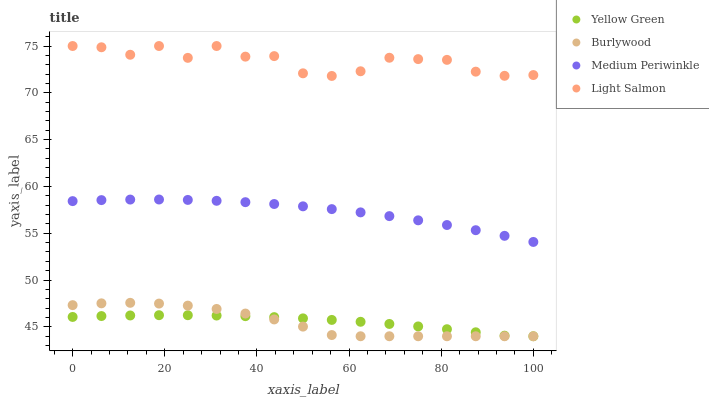Does Burlywood have the minimum area under the curve?
Answer yes or no. Yes. Does Light Salmon have the maximum area under the curve?
Answer yes or no. Yes. Does Medium Periwinkle have the minimum area under the curve?
Answer yes or no. No. Does Medium Periwinkle have the maximum area under the curve?
Answer yes or no. No. Is Yellow Green the smoothest?
Answer yes or no. Yes. Is Light Salmon the roughest?
Answer yes or no. Yes. Is Medium Periwinkle the smoothest?
Answer yes or no. No. Is Medium Periwinkle the roughest?
Answer yes or no. No. Does Burlywood have the lowest value?
Answer yes or no. Yes. Does Medium Periwinkle have the lowest value?
Answer yes or no. No. Does Light Salmon have the highest value?
Answer yes or no. Yes. Does Medium Periwinkle have the highest value?
Answer yes or no. No. Is Burlywood less than Medium Periwinkle?
Answer yes or no. Yes. Is Light Salmon greater than Medium Periwinkle?
Answer yes or no. Yes. Does Burlywood intersect Yellow Green?
Answer yes or no. Yes. Is Burlywood less than Yellow Green?
Answer yes or no. No. Is Burlywood greater than Yellow Green?
Answer yes or no. No. Does Burlywood intersect Medium Periwinkle?
Answer yes or no. No. 